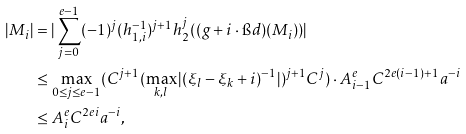<formula> <loc_0><loc_0><loc_500><loc_500>| M _ { i } | & = | \sum _ { j = 0 } ^ { e - 1 } ( - 1 ) ^ { j } ( h _ { 1 , i } ^ { - 1 } ) ^ { j + 1 } h _ { 2 } ^ { j } ( ( g + i \cdot \i d ) ( M _ { i } ) ) | \\ & \leq \max _ { 0 \leq j \leq e - 1 } ( C ^ { j + 1 } ( \max _ { k , l } | ( \xi _ { l } - \xi _ { k } + i ) ^ { - 1 } | ) ^ { j + 1 } C ^ { j } ) \cdot A _ { i - 1 } ^ { e } C ^ { 2 e ( i - 1 ) + 1 } a ^ { - i } \\ & \leq A _ { i } ^ { e } C ^ { 2 e i } a ^ { - i } ,</formula> 